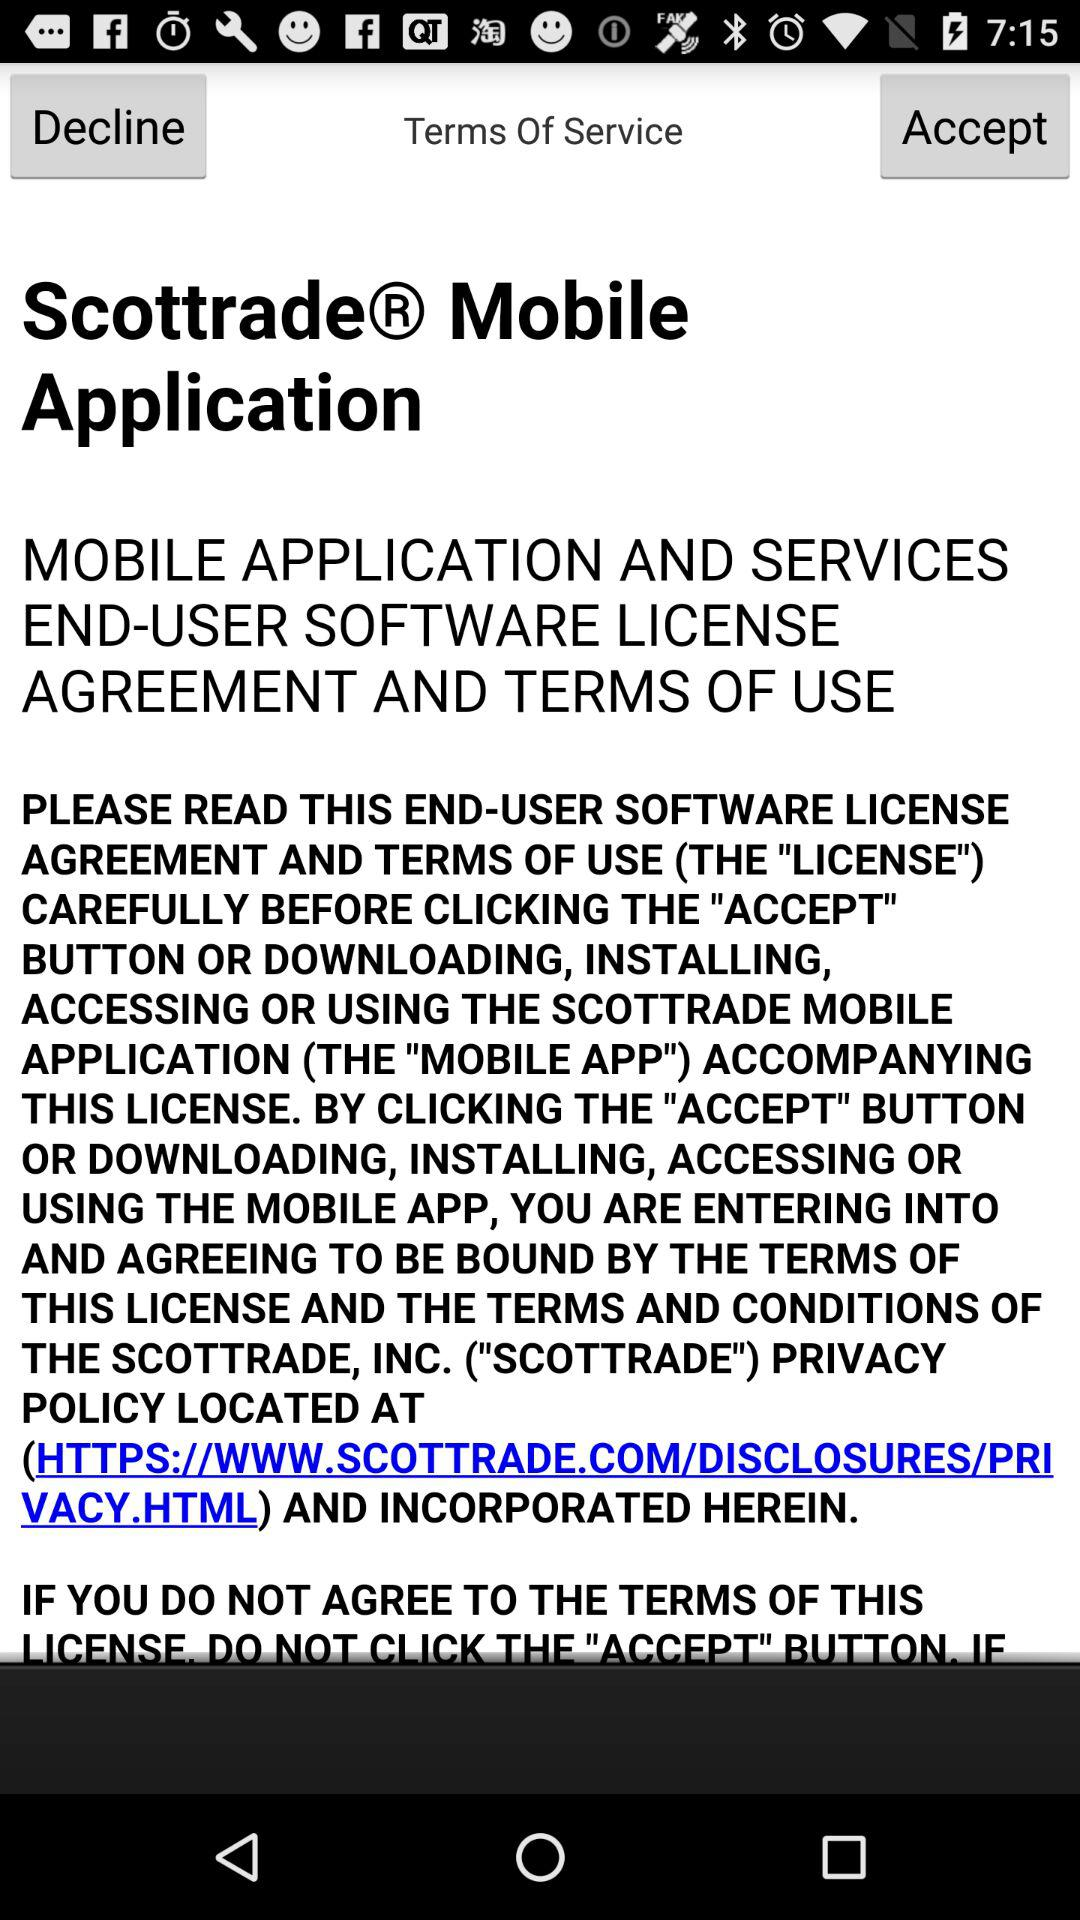Where can I find the Scottrade, Inc. privacy policy's terms and conditions? The Scottrade, Inc. privacy policy's terms and conditions is HTTPS://WWW.SCOTTRADE.COM/DISCLOSURES/PRIVACY.HTML. 